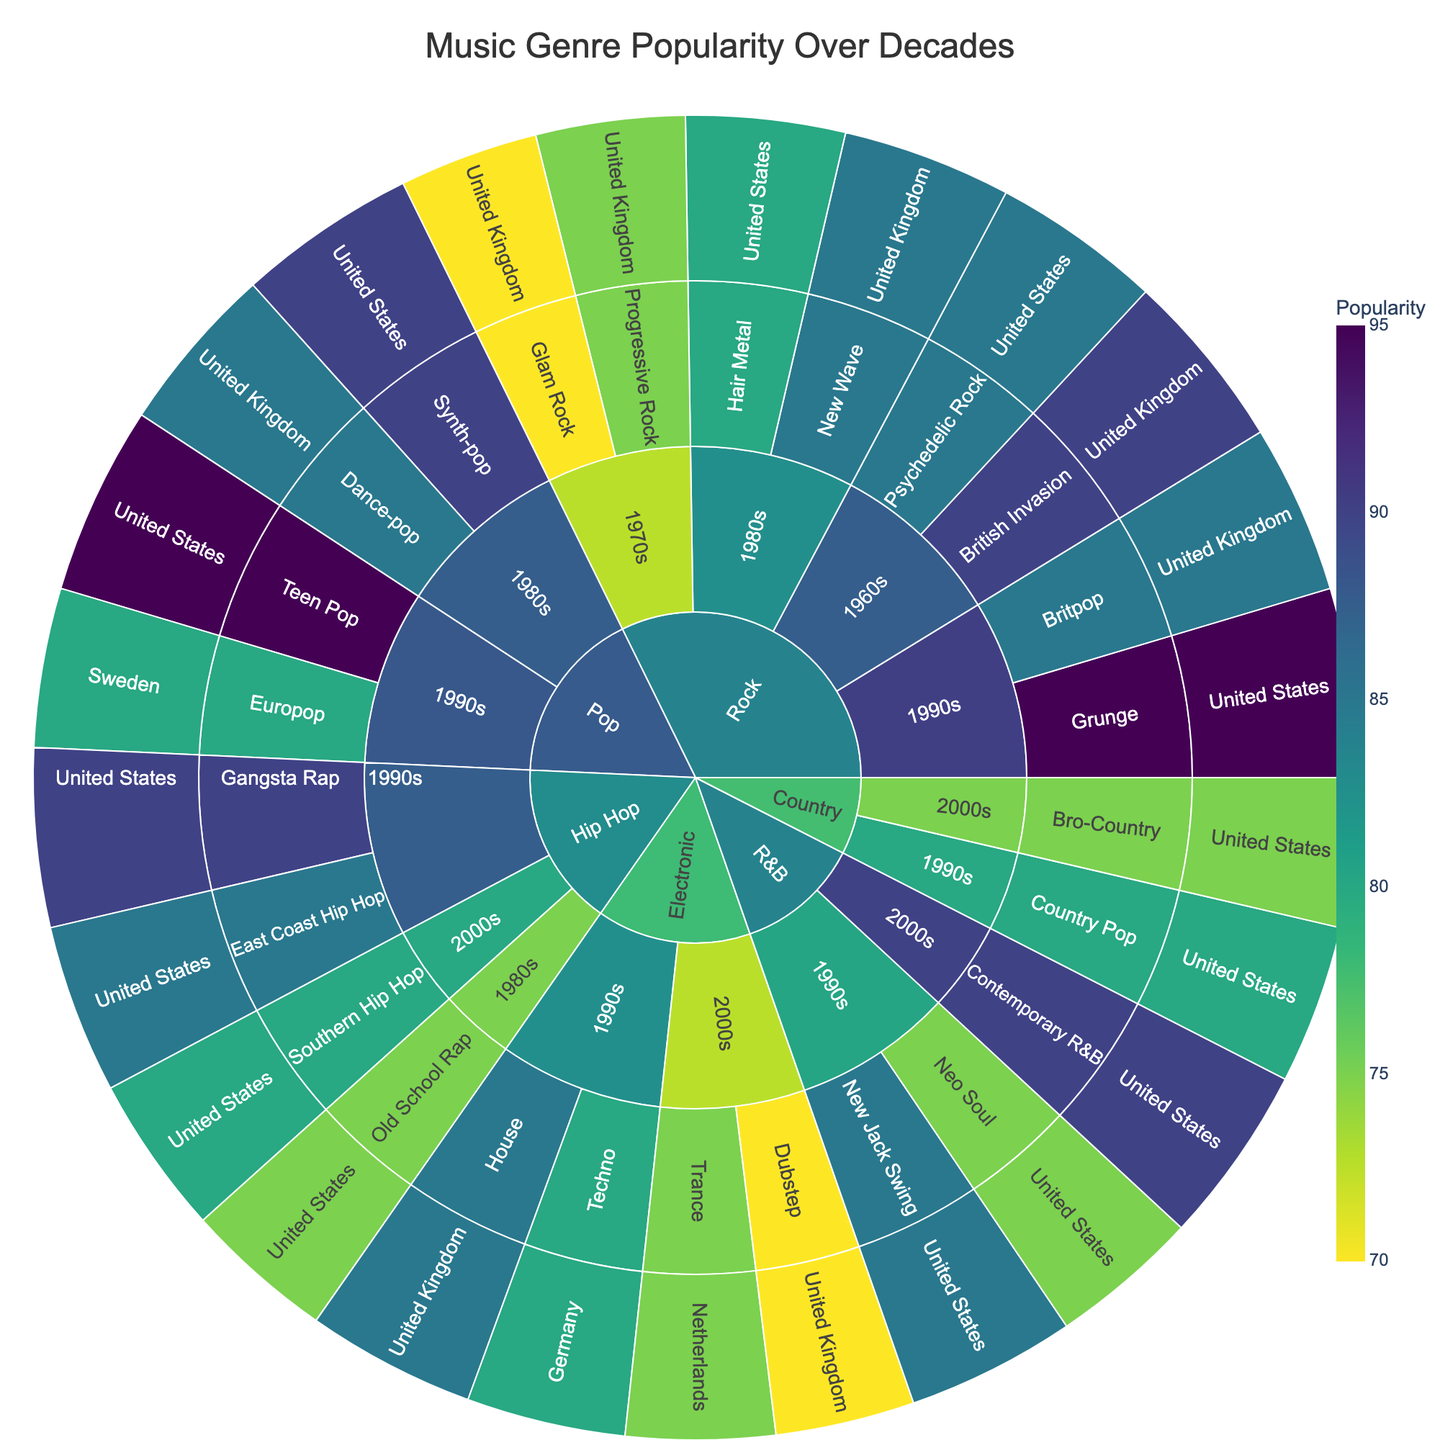What is the title of the Sunburst Plot? The title of the plot is typically located at the top center of the figure. It's designed to give a high-level idea about the data being visualized. By reading the title directly from the figure, you can identify what the plot is about.
Answer: Music Genre Popularity Over Decades Which genre had the highest popularity in the 1990s? To determine this, you need to look at the branches stemming from the 1990s node and see which subgenres have the highest values.
Answer: Rock What is the regional influence on Synth-pop in the 1980s? Find the Synth-pop node under the 1980s branch and see which region it is associated with.
Answer: United States Compare the popularity of Teen Pop and New Jack Swing in the 1990s. Which was more popular and by how much? Locate both Teen Pop and New Jack Swing under the 1990s node, note their popularity values, then subtract the smaller value from the larger one to find the difference.
Answer: Teen Pop was more popular by 10 Which subgenre under Hip Hop in the 1990s had the lowest popularity? Within the 1990s -> Hip Hop branch, look at the subgenre values and identify the smallest one.
Answer: East Coast Hip Hop How does the popularity of House in the 1990s compare to Trance in the 2000s? Locate both House under the 1990s -> Electronic and Trance under the 2000s -> Electronic nodes, note their popularity values, and compare them.
Answer: House is more popular by 10 What decade has the most diverse subgenres under Rock? Check the number of subgenres listed under the Rock branches for each decade and identify which has the most.
Answer: 1990s Which subgenre in the 1980s has the highest popularity, and from which region? Within the 1980s node, look for the subgenre with the highest popularity value and note its associated region.
Answer: British Invasion from the United Kingdom How does the popularity of Neo Soul in the 1990s compare to that of Dubstep in the 2000s? Locate both Neo Soul under the 1990s -> R&B and Dubstep under the 2000s -> Electronic nodes, note their popularity values, and compare them.
Answer: Neo Soul is more popular by 5 